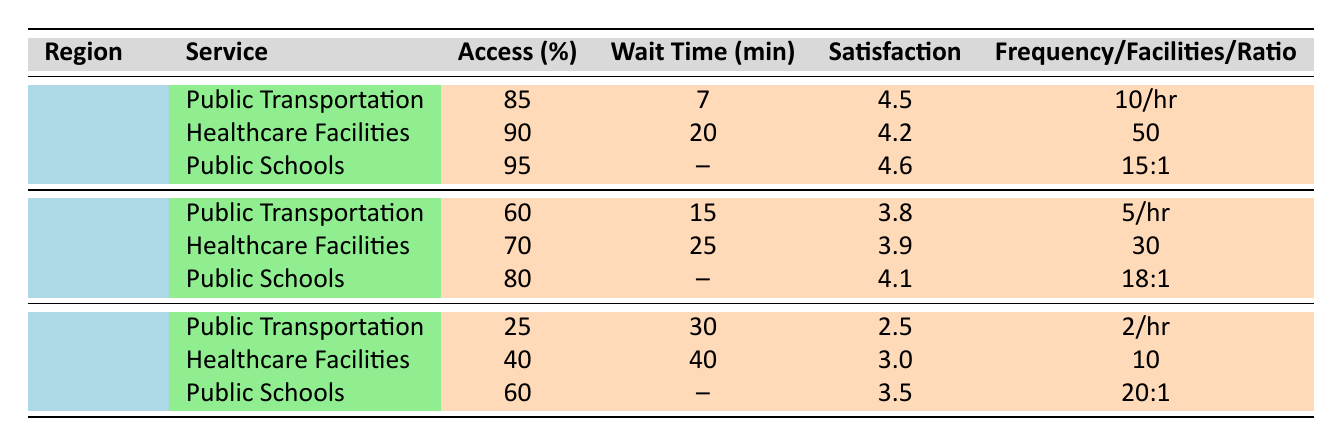What is the average user satisfaction rating for Public Transportation in Urban areas? The user satisfaction rating for Public Transportation in Urban areas is given as 4.5. There is only one entry for this service in the Urban region, so the average is simply this value.
Answer: 4.5 What percentage of access to Healthcare Facilities is reported in Rural areas? The access percentage for Healthcare Facilities in Rural areas is listed in the table as 40%. This value can be directly retrieved from the table.
Answer: 40% What is the average wait time for Healthcare Facilities across all regions? The average wait time can be calculated by taking the sum of the wait times for each region's Healthcare Facilities (20 + 25 + 40 = 85 minutes) and dividing by the number of regions (3). Thus, the average wait time is 85 / 3 = 28.33 minutes.
Answer: 28.33 Is the access percentage for Public Schools in Suburban areas higher than that in Rural areas? For Suburban areas, the access percentage for Public Schools is 80%, while for Rural areas it is 60%. Since 80 is greater than 60, the statement is true.
Answer: Yes Which region has the lowest access percentage for Public Transportation, and what is that percentage? The Rural region has an access percentage of 25%, which is the lowest compared to Urban (85%) and Suburban (60%). Thus the lowest percentage is in Rural.
Answer: 25% What is the difference in user satisfaction ratings between Public Schools in Urban and Rural areas? The user satisfaction rating for Public Schools in Urban areas is 4.6, while in Rural areas it is 3.5. The difference is calculated as 4.6 - 3.5 = 1.1.
Answer: 1.1 Are the average wait times for Public Transportation in Suburban areas better than those in Rural areas? The average wait time for Suburban is 15 minutes, while for Rural it is 30 minutes. Since 15 is less than 30, Public Transportation in Suburban areas has a better wait time.
Answer: Yes What is the total number of Healthcare Facilities reported in Urban areas? The table states that there are 50 Healthcare Facilities in Urban areas. This number is directly referenced in the entry for that region.
Answer: 50 What is the student-teacher ratio for Public Schools in Rural areas? The student-teacher ratio for Public Schools in Rural areas is provided as 20:1, which can be directly found in the table.
Answer: 20:1 Which service has the highest user satisfaction rating in the table, and what is that rating? Public Schools in Urban areas have the highest user satisfaction rating at 4.6. This is in comparison to the other services listed, which have lower ratings.
Answer: 4.6 What is the combined access percentage for Healthcare Facilities in Suburban and Rural areas? The access percentage for Healthcare Facilities in Suburban areas is 70% and in Rural areas is 40%. The combined access percentage is calculated as 70 + 40 = 110%.
Answer: 110% 